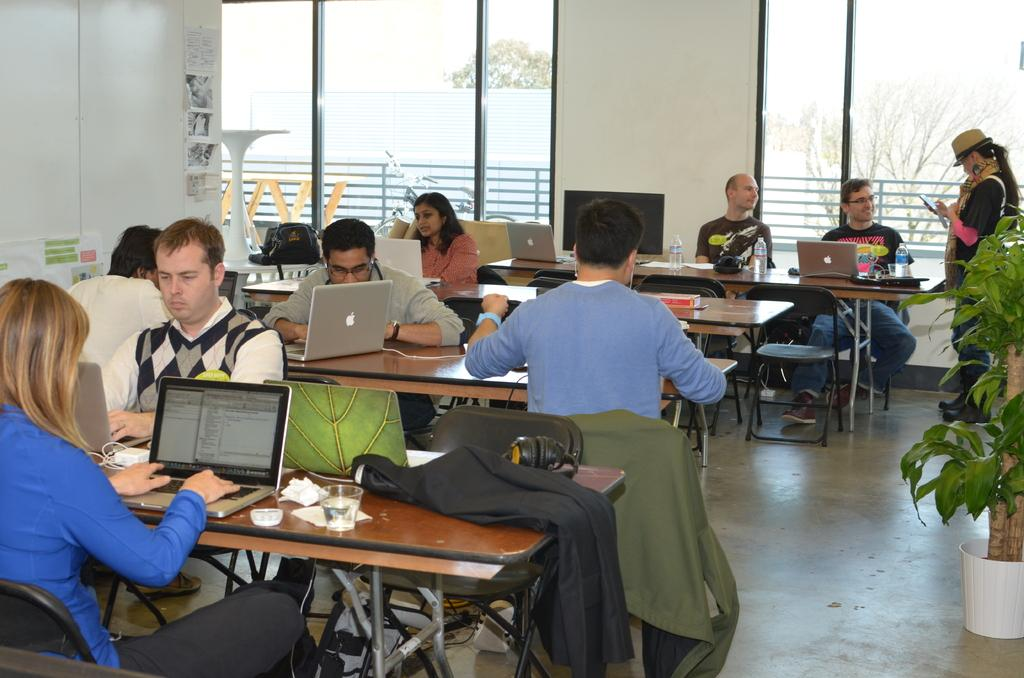What are the people in the image doing while sitting on chairs? The people in the image are working on laptops. Can you describe the setting in which the people are working? There is a plant on the right side of the image and a glass wall on the left side of the image. What type of flesh can be seen on the plant in the image? There is no flesh visible on the plant in the image, as plants do not have flesh. 